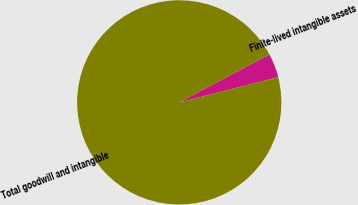Convert chart to OTSL. <chart><loc_0><loc_0><loc_500><loc_500><pie_chart><fcel>Finite-lived intangible assets<fcel>Total goodwill and intangible<nl><fcel>3.81%<fcel>96.19%<nl></chart> 